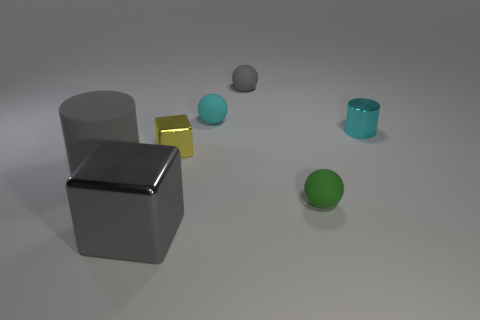Add 1 tiny yellow rubber cubes. How many objects exist? 8 Subtract all blocks. How many objects are left? 5 Subtract all tiny gray matte things. Subtract all small things. How many objects are left? 1 Add 6 small cyan matte objects. How many small cyan matte objects are left? 7 Add 5 small red rubber cylinders. How many small red rubber cylinders exist? 5 Subtract 0 green cylinders. How many objects are left? 7 